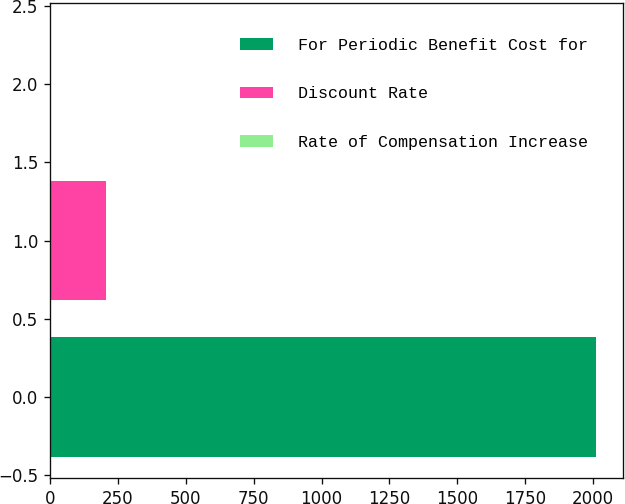Convert chart to OTSL. <chart><loc_0><loc_0><loc_500><loc_500><bar_chart><fcel>For Periodic Benefit Cost for<fcel>Discount Rate<fcel>Rate of Compensation Increase<nl><fcel>2009<fcel>204.95<fcel>4.5<nl></chart> 